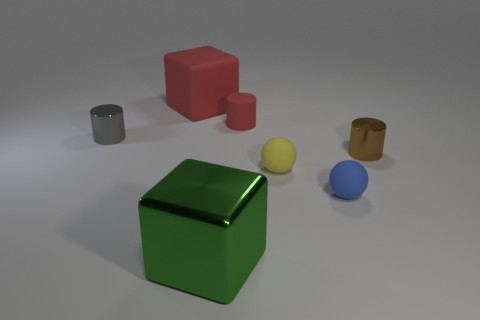The brown object that is the same shape as the gray metal thing is what size?
Your answer should be very brief. Small. Is the color of the large metallic block the same as the small rubber cylinder?
Make the answer very short. No. How many other things are there of the same material as the tiny blue object?
Provide a succinct answer. 3. Is the number of tiny cylinders that are left of the green metallic object the same as the number of gray things?
Offer a very short reply. Yes. Does the rubber ball that is in front of the yellow matte sphere have the same size as the big green block?
Your answer should be very brief. No. What number of tiny brown metallic objects are in front of the big green block?
Make the answer very short. 0. There is a thing that is on the right side of the yellow matte sphere and behind the blue matte thing; what material is it?
Ensure brevity in your answer.  Metal. How many big objects are either gray cylinders or blocks?
Give a very brief answer. 2. How big is the gray cylinder?
Your response must be concise. Small. There is a large green object; what shape is it?
Give a very brief answer. Cube. 